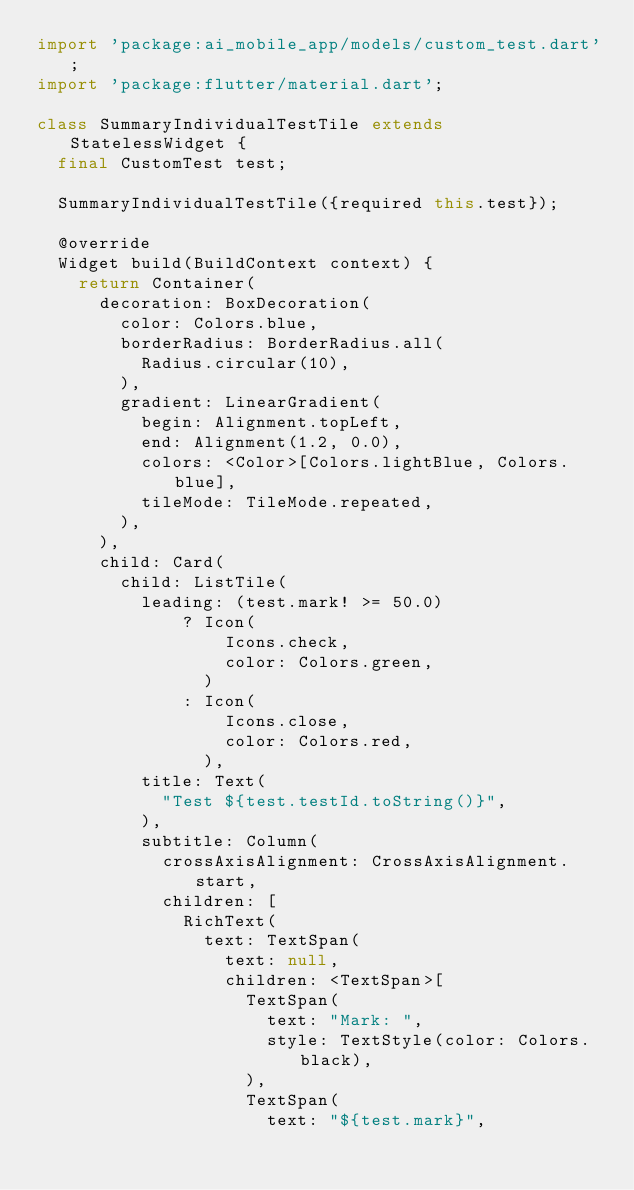Convert code to text. <code><loc_0><loc_0><loc_500><loc_500><_Dart_>import 'package:ai_mobile_app/models/custom_test.dart';
import 'package:flutter/material.dart';

class SummaryIndividualTestTile extends StatelessWidget {
  final CustomTest test;

  SummaryIndividualTestTile({required this.test});

  @override
  Widget build(BuildContext context) {
    return Container(
      decoration: BoxDecoration(
        color: Colors.blue,
        borderRadius: BorderRadius.all(
          Radius.circular(10),
        ),
        gradient: LinearGradient(
          begin: Alignment.topLeft,
          end: Alignment(1.2, 0.0),
          colors: <Color>[Colors.lightBlue, Colors.blue],
          tileMode: TileMode.repeated,
        ),
      ),
      child: Card(
        child: ListTile(
          leading: (test.mark! >= 50.0)
              ? Icon(
                  Icons.check,
                  color: Colors.green,
                )
              : Icon(
                  Icons.close,
                  color: Colors.red,
                ),
          title: Text(
            "Test ${test.testId.toString()}",
          ),
          subtitle: Column(
            crossAxisAlignment: CrossAxisAlignment.start,
            children: [
              RichText(
                text: TextSpan(
                  text: null,
                  children: <TextSpan>[
                    TextSpan(
                      text: "Mark: ",
                      style: TextStyle(color: Colors.black),
                    ),
                    TextSpan(
                      text: "${test.mark}",</code> 